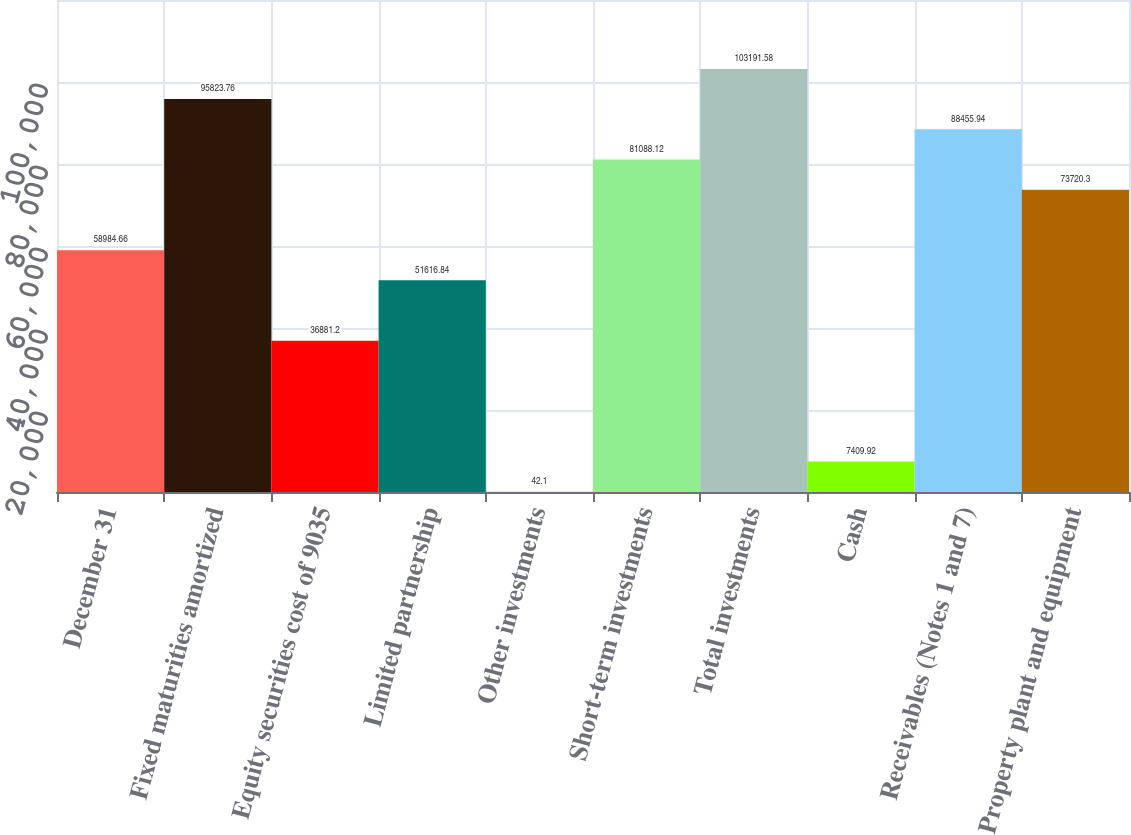<chart> <loc_0><loc_0><loc_500><loc_500><bar_chart><fcel>December 31<fcel>Fixed maturities amortized<fcel>Equity securities cost of 9035<fcel>Limited partnership<fcel>Other investments<fcel>Short-term investments<fcel>Total investments<fcel>Cash<fcel>Receivables (Notes 1 and 7)<fcel>Property plant and equipment<nl><fcel>58984.7<fcel>95823.8<fcel>36881.2<fcel>51616.8<fcel>42.1<fcel>81088.1<fcel>103192<fcel>7409.92<fcel>88455.9<fcel>73720.3<nl></chart> 